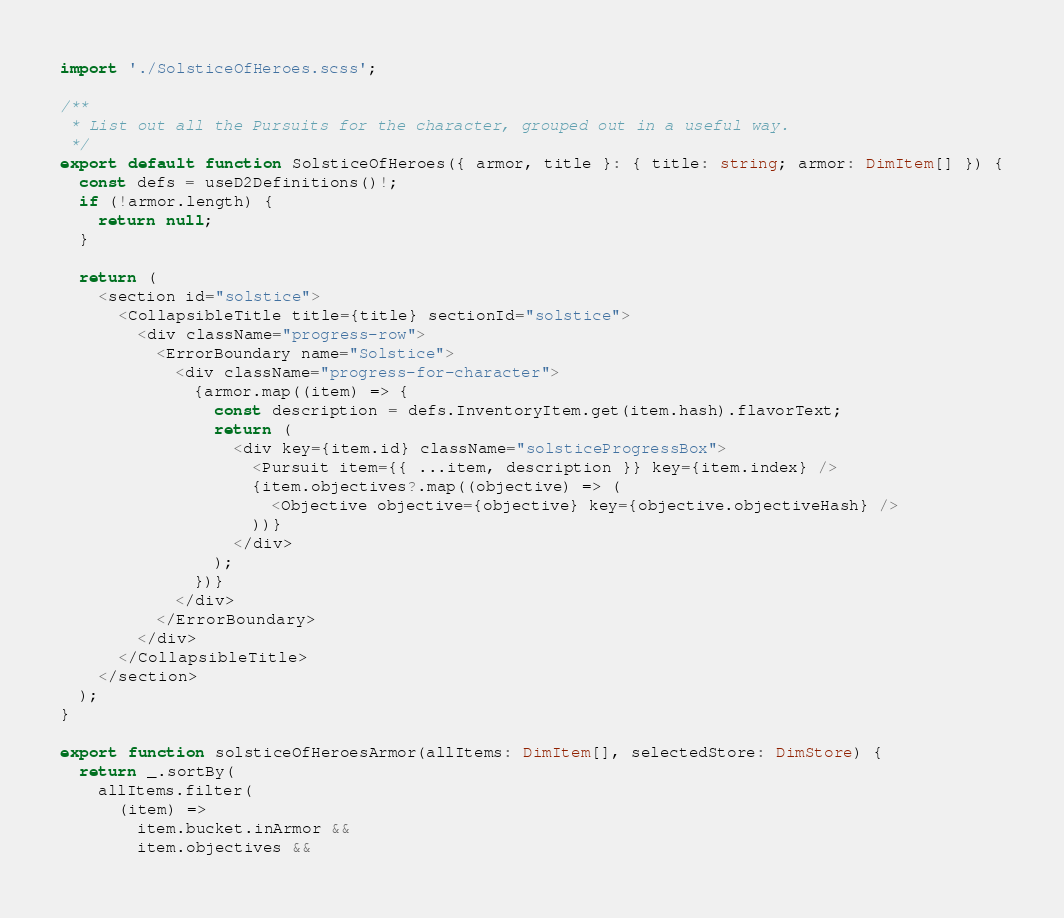<code> <loc_0><loc_0><loc_500><loc_500><_TypeScript_>import './SolsticeOfHeroes.scss';

/**
 * List out all the Pursuits for the character, grouped out in a useful way.
 */
export default function SolsticeOfHeroes({ armor, title }: { title: string; armor: DimItem[] }) {
  const defs = useD2Definitions()!;
  if (!armor.length) {
    return null;
  }

  return (
    <section id="solstice">
      <CollapsibleTitle title={title} sectionId="solstice">
        <div className="progress-row">
          <ErrorBoundary name="Solstice">
            <div className="progress-for-character">
              {armor.map((item) => {
                const description = defs.InventoryItem.get(item.hash).flavorText;
                return (
                  <div key={item.id} className="solsticeProgressBox">
                    <Pursuit item={{ ...item, description }} key={item.index} />
                    {item.objectives?.map((objective) => (
                      <Objective objective={objective} key={objective.objectiveHash} />
                    ))}
                  </div>
                );
              })}
            </div>
          </ErrorBoundary>
        </div>
      </CollapsibleTitle>
    </section>
  );
}

export function solsticeOfHeroesArmor(allItems: DimItem[], selectedStore: DimStore) {
  return _.sortBy(
    allItems.filter(
      (item) =>
        item.bucket.inArmor &&
        item.objectives &&</code> 